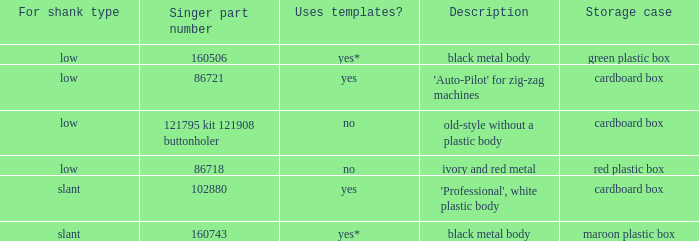What's the shank type of the buttonholer with red plastic box as storage case? Low. 